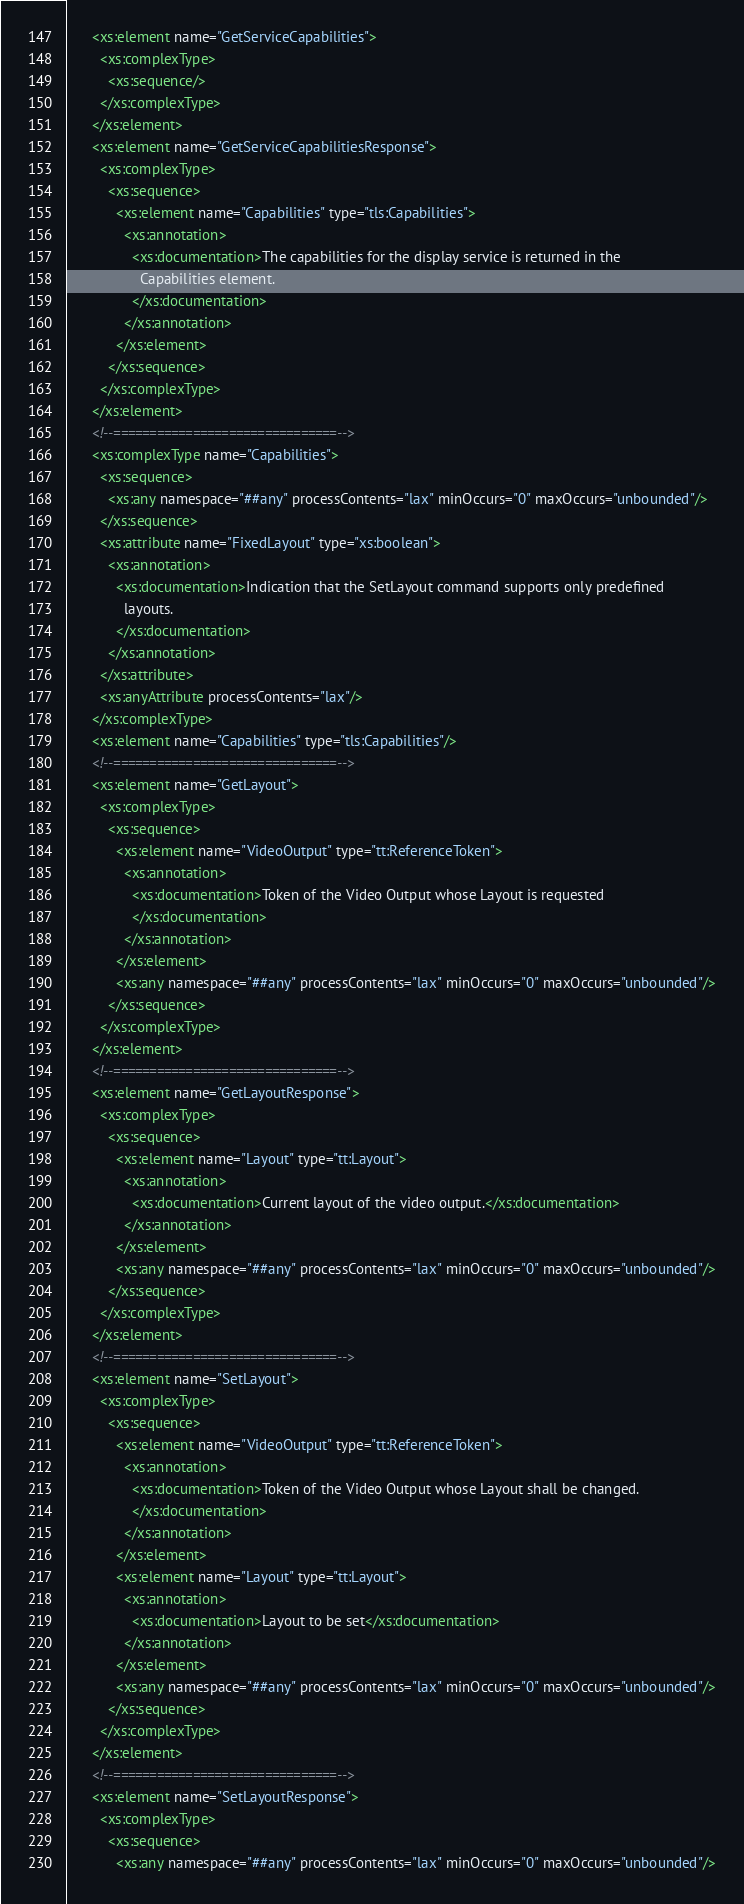Convert code to text. <code><loc_0><loc_0><loc_500><loc_500><_XML_>      <xs:element name="GetServiceCapabilities">
        <xs:complexType>
          <xs:sequence/>
        </xs:complexType>
      </xs:element>
      <xs:element name="GetServiceCapabilitiesResponse">
        <xs:complexType>
          <xs:sequence>
            <xs:element name="Capabilities" type="tls:Capabilities">
              <xs:annotation>
                <xs:documentation>The capabilities for the display service is returned in the
                  Capabilities element.
                </xs:documentation>
              </xs:annotation>
            </xs:element>
          </xs:sequence>
        </xs:complexType>
      </xs:element>
      <!--===============================-->
      <xs:complexType name="Capabilities">
        <xs:sequence>
          <xs:any namespace="##any" processContents="lax" minOccurs="0" maxOccurs="unbounded"/>
        </xs:sequence>
        <xs:attribute name="FixedLayout" type="xs:boolean">
          <xs:annotation>
            <xs:documentation>Indication that the SetLayout command supports only predefined
              layouts.
            </xs:documentation>
          </xs:annotation>
        </xs:attribute>
        <xs:anyAttribute processContents="lax"/>
      </xs:complexType>
      <xs:element name="Capabilities" type="tls:Capabilities"/>
      <!--===============================-->
      <xs:element name="GetLayout">
        <xs:complexType>
          <xs:sequence>
            <xs:element name="VideoOutput" type="tt:ReferenceToken">
              <xs:annotation>
                <xs:documentation>Token of the Video Output whose Layout is requested
                </xs:documentation>
              </xs:annotation>
            </xs:element>
            <xs:any namespace="##any" processContents="lax" minOccurs="0" maxOccurs="unbounded"/>
          </xs:sequence>
        </xs:complexType>
      </xs:element>
      <!--===============================-->
      <xs:element name="GetLayoutResponse">
        <xs:complexType>
          <xs:sequence>
            <xs:element name="Layout" type="tt:Layout">
              <xs:annotation>
                <xs:documentation>Current layout of the video output.</xs:documentation>
              </xs:annotation>
            </xs:element>
            <xs:any namespace="##any" processContents="lax" minOccurs="0" maxOccurs="unbounded"/>
          </xs:sequence>
        </xs:complexType>
      </xs:element>
      <!--===============================-->
      <xs:element name="SetLayout">
        <xs:complexType>
          <xs:sequence>
            <xs:element name="VideoOutput" type="tt:ReferenceToken">
              <xs:annotation>
                <xs:documentation>Token of the Video Output whose Layout shall be changed.
                </xs:documentation>
              </xs:annotation>
            </xs:element>
            <xs:element name="Layout" type="tt:Layout">
              <xs:annotation>
                <xs:documentation>Layout to be set</xs:documentation>
              </xs:annotation>
            </xs:element>
            <xs:any namespace="##any" processContents="lax" minOccurs="0" maxOccurs="unbounded"/>
          </xs:sequence>
        </xs:complexType>
      </xs:element>
      <!--===============================-->
      <xs:element name="SetLayoutResponse">
        <xs:complexType>
          <xs:sequence>
            <xs:any namespace="##any" processContents="lax" minOccurs="0" maxOccurs="unbounded"/></code> 